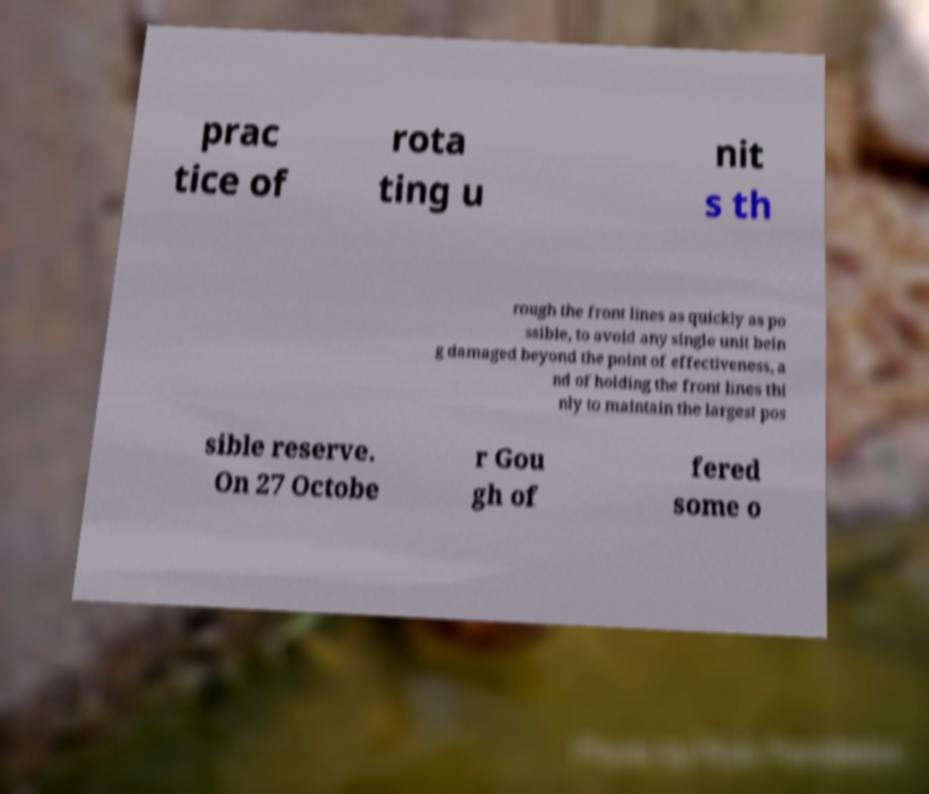Could you assist in decoding the text presented in this image and type it out clearly? prac tice of rota ting u nit s th rough the front lines as quickly as po ssible, to avoid any single unit bein g damaged beyond the point of effectiveness, a nd of holding the front lines thi nly to maintain the largest pos sible reserve. On 27 Octobe r Gou gh of fered some o 